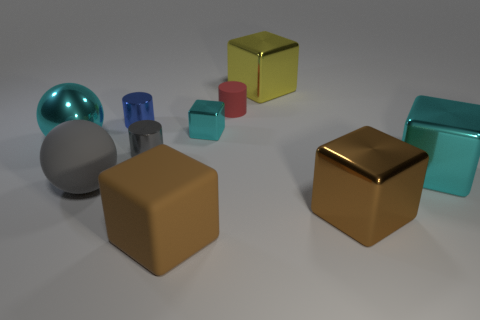Does the small cylinder behind the blue object have the same material as the tiny cube?
Keep it short and to the point. No. How many tiny matte objects have the same shape as the yellow shiny object?
Keep it short and to the point. 0. What number of big things are red rubber objects or yellow metal blocks?
Your answer should be compact. 1. Does the large matte object behind the large rubber cube have the same color as the tiny rubber cylinder?
Provide a succinct answer. No. Does the big cube on the left side of the yellow block have the same color as the big shiny object left of the large yellow object?
Offer a very short reply. No. Are there any other small red things that have the same material as the red object?
Provide a short and direct response. No. What number of red objects are either rubber balls or metal spheres?
Your response must be concise. 0. Are there more tiny blue cylinders in front of the big shiny sphere than large brown metal cubes?
Ensure brevity in your answer.  No. Do the cyan metal sphere and the red thing have the same size?
Provide a short and direct response. No. The large ball that is the same material as the small red object is what color?
Your response must be concise. Gray. 